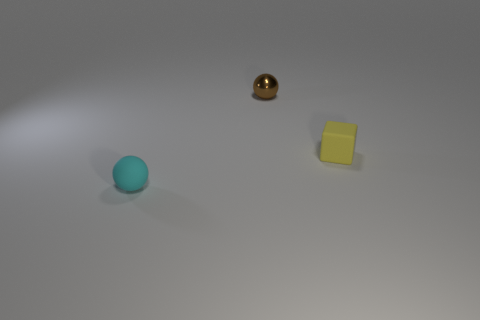Add 1 small red metal objects. How many objects exist? 4 Subtract all spheres. How many objects are left? 1 Subtract 0 blue cubes. How many objects are left? 3 Subtract all brown cubes. Subtract all small yellow blocks. How many objects are left? 2 Add 2 tiny rubber blocks. How many tiny rubber blocks are left? 3 Add 1 big purple cylinders. How many big purple cylinders exist? 1 